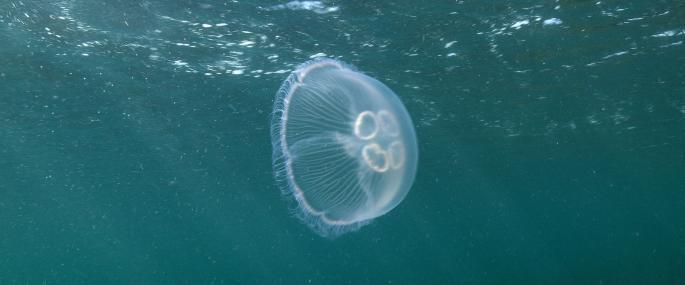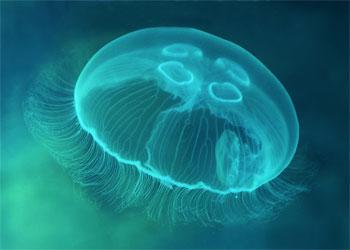The first image is the image on the left, the second image is the image on the right. For the images shown, is this caption "the jellyfish in the left image is swimming to the right" true? Answer yes or no. Yes. The first image is the image on the left, the second image is the image on the right. Assess this claim about the two images: "The jellyfish in the image to the left has a distinct clover type image visible within its body.". Correct or not? Answer yes or no. Yes. 